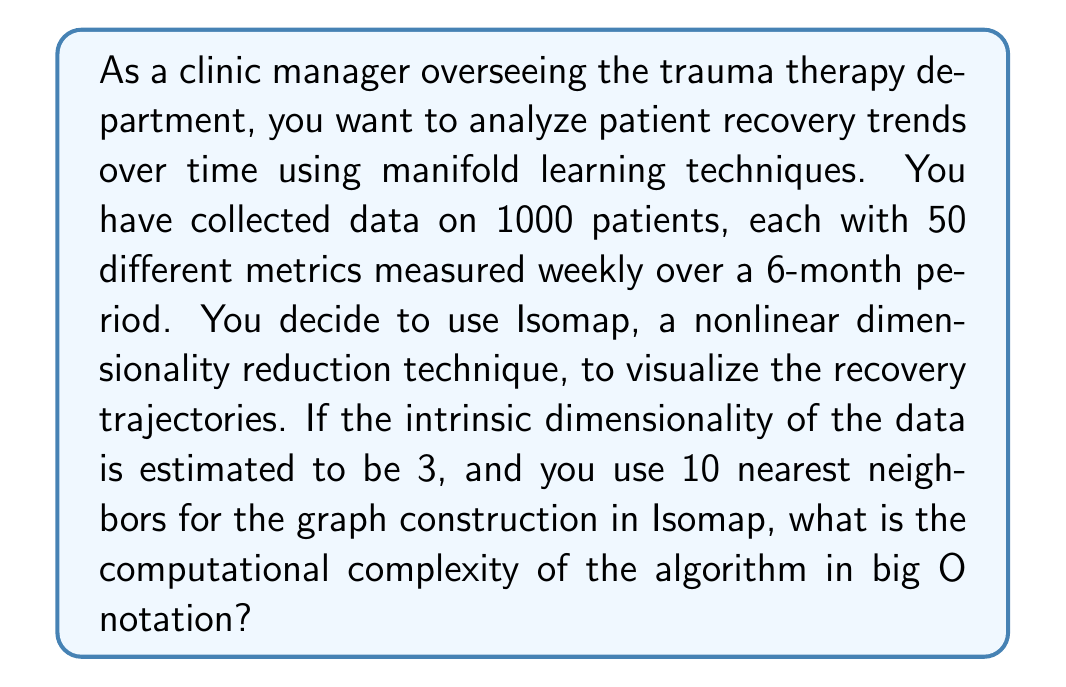Could you help me with this problem? To determine the computational complexity of Isomap in this scenario, we need to consider the main steps of the algorithm:

1. Construct the nearest neighbor graph:
   - For each of the $n$ points (where $n = 1000 \times 26 = 26000$, as we have weekly data for 6 months), we need to compute distances to all other points and find the $k$ nearest neighbors (where $k = 10$).
   - This step has a complexity of $O(n^2d + n^2\log k)$, where $d$ is the original dimensionality (50 in this case).

2. Compute shortest paths:
   - Using Floyd-Warshall or Dijkstra's algorithm for all pairs of points.
   - This step has a complexity of $O(n^3)$ for Floyd-Warshall or $O(n^2\log n)$ for Dijkstra's.

3. Perform Multidimensional Scaling (MDS):
   - This involves eigendecomposition of an $n \times n$ matrix.
   - The complexity of this step is $O(n^3)$.

The overall complexity is dominated by the most expensive step, which is either the shortest path computation or the MDS step, both with $O(n^3)$ complexity.

Therefore, the computational complexity of Isomap in this scenario is $O(n^3)$, where $n = 26000$.

It's worth noting that there are approximate versions of Isomap that can reduce this complexity, but the question asks for the standard implementation.
Answer: $O(n^3)$, where $n = 26000$ 